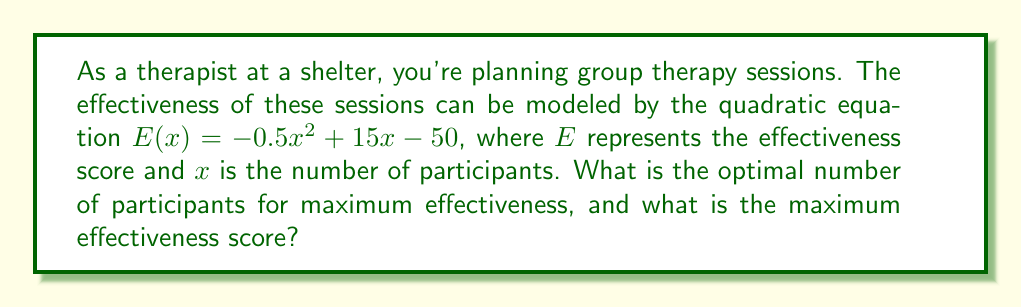Provide a solution to this math problem. To solve this problem, we need to follow these steps:

1) The effectiveness function is given by:
   $E(x) = -0.5x^2 + 15x - 50$

2) This is a quadratic function, and its graph is a parabola that opens downward (because the coefficient of $x^2$ is negative). The maximum point of this parabola will give us the optimal number of participants and the maximum effectiveness score.

3) To find the maximum point, we need to find the vertex of the parabola. For a quadratic function in the form $f(x) = ax^2 + bx + c$, the x-coordinate of the vertex is given by $x = -\frac{b}{2a}$.

4) In our case, $a = -0.5$, $b = 15$, and $c = -50$. So:

   $x = -\frac{15}{2(-0.5)} = -\frac{15}{-1} = 15$

5) This means the optimal number of participants is 15.

6) To find the maximum effectiveness score, we need to calculate $E(15)$:

   $E(15) = -0.5(15)^2 + 15(15) - 50$
   $= -0.5(225) + 225 - 50$
   $= -112.5 + 225 - 50$
   $= 62.5$

Therefore, the maximum effectiveness score is 62.5.
Answer: The optimal number of participants is 15, and the maximum effectiveness score is 62.5. 